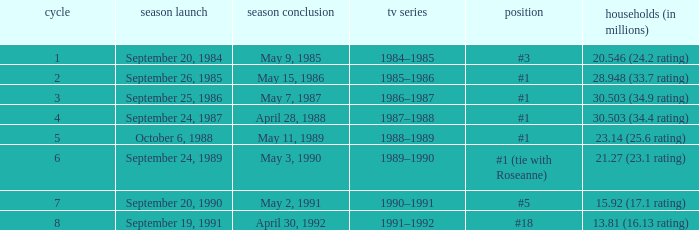Which TV season has a Season larger than 2, and a Ranking of #5? 1990–1991. 